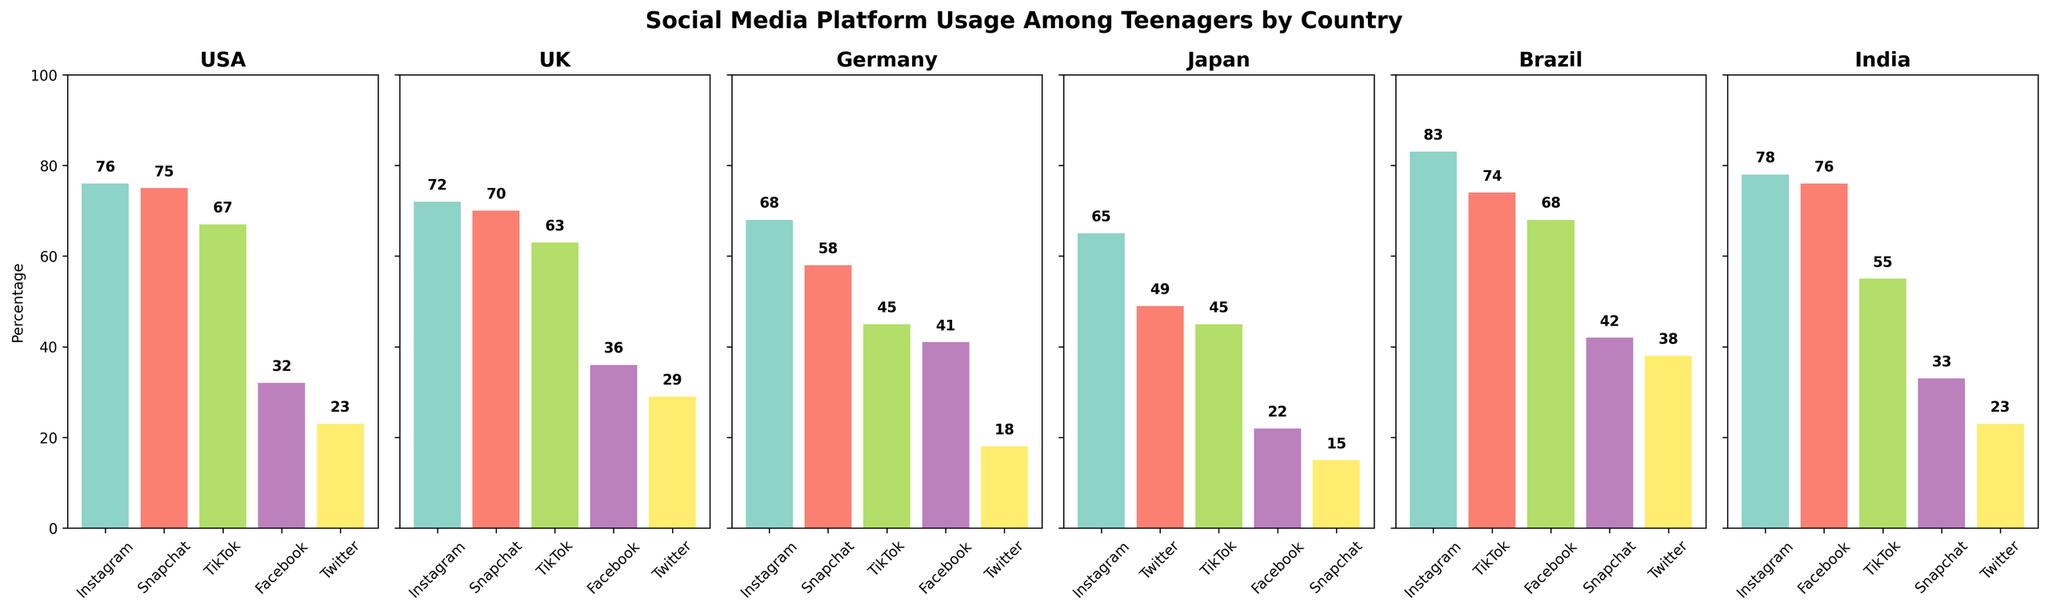Which country has the highest percentage of Instagram usage among teenagers? From the figure, observe the height of the bars representing Instagram usage in all countries. Identify the country with the tallest bar. The USA has 76%, the UK 72%, Germany 68%, Japan 65%, Brazil 83%, and India 78%. Therefore, Brazil has the highest percentage.
Answer: Brazil Which country shows the least percentage of Twitter usage? Compare the height of the bars representing Twitter usage across all countries. The USA has 23%, the UK 29%, Germany 18%, Japan 49%, Brazil 38%, and India 23%. Thus, Germany has the least percentage.
Answer: Germany Calculate the average Snapchat usage percentage for the USA and the UK. Find the Snapchat usage percentages for the USA (75%) and the UK (70%). Calculate the average: \( \frac{75 + 70}{2} = 72.5 \).
Answer: 72.5 Is TikTok more popular than Facebook among teenagers in Japan? Compare the heights of the TikTok (45%) and Facebook (22%) bars in Japan. The TikTok bar is taller.
Answer: Yes Which platform has the highest usage percentage in Brazil and what is it? Look at the bar heights for different platforms in Brazil. The tallest bar represents Instagram at 83%.
Answer: Instagram, 83% Which country has the biggest difference between Instagram and Snapchat usage? Calculate the differences between Instagram and Snapchat usage in all countries. The differences are: USA (76-75=1), UK (72-70=2), Germany (68-58=10), Japan (65-15=50), Brazil (83-42=41), and India (78-33=45). The biggest difference is in Japan.
Answer: Japan Compare the total percentage usage of all platforms between the USA and Germany. Which is higher? Sum all platform usage percentages for the USA: \( 76 + 75 + 67 + 32 + 23 = 273 \); for Germany: \( 68 + 58 + 45 + 41 + 18 = 230 \). The USA has a higher total percentage.
Answer: USA How does the popularity of Facebook vary among teenagers in India and the UK? Observe and compare the heights of the Facebook bars. India has 76%, while the UK has 36%. Facebook is more popular in India.
Answer: India What is the difference in Snapchat usage between Germany and Japan? Find the Snapchat usage percentages for Germany (58%) and Japan (15%). Calculate the difference: \( 58 - 15 = 43 \).
Answer: 43 